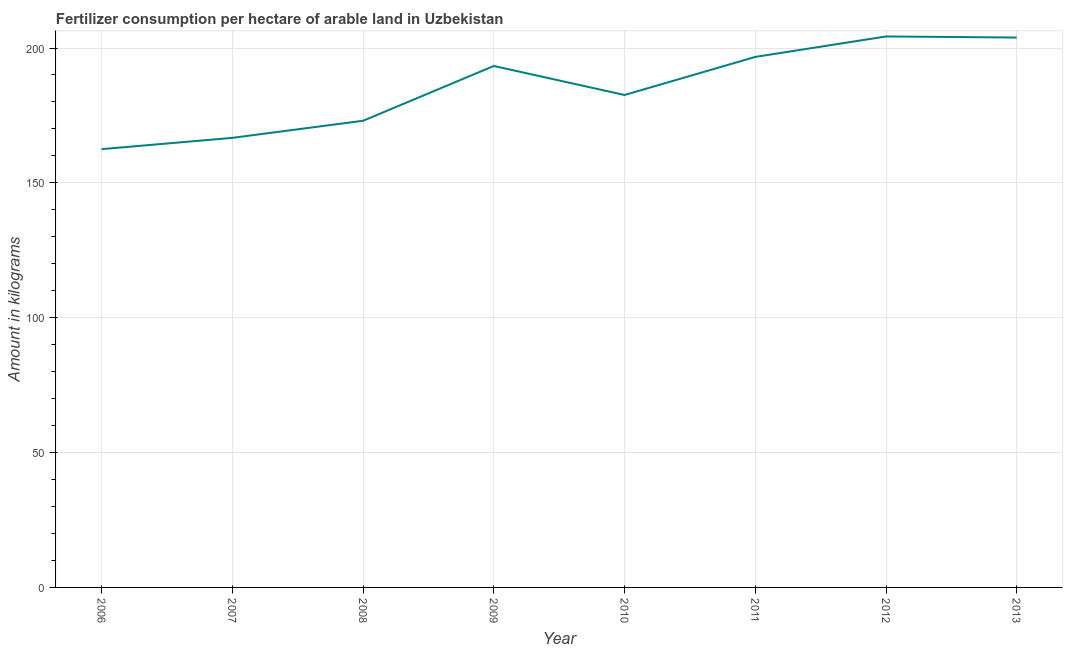What is the amount of fertilizer consumption in 2012?
Give a very brief answer. 204.28. Across all years, what is the maximum amount of fertilizer consumption?
Offer a terse response. 204.28. Across all years, what is the minimum amount of fertilizer consumption?
Provide a succinct answer. 162.5. In which year was the amount of fertilizer consumption minimum?
Keep it short and to the point. 2006. What is the sum of the amount of fertilizer consumption?
Give a very brief answer. 1482.98. What is the difference between the amount of fertilizer consumption in 2009 and 2011?
Give a very brief answer. -3.36. What is the average amount of fertilizer consumption per year?
Make the answer very short. 185.37. What is the median amount of fertilizer consumption?
Provide a succinct answer. 187.96. In how many years, is the amount of fertilizer consumption greater than 90 kg?
Your response must be concise. 8. What is the ratio of the amount of fertilizer consumption in 2009 to that in 2011?
Provide a short and direct response. 0.98. Is the amount of fertilizer consumption in 2006 less than that in 2011?
Make the answer very short. Yes. Is the difference between the amount of fertilizer consumption in 2011 and 2012 greater than the difference between any two years?
Ensure brevity in your answer.  No. What is the difference between the highest and the second highest amount of fertilizer consumption?
Your answer should be compact. 0.4. What is the difference between the highest and the lowest amount of fertilizer consumption?
Your answer should be very brief. 41.78. Does the amount of fertilizer consumption monotonically increase over the years?
Provide a succinct answer. No. What is the difference between two consecutive major ticks on the Y-axis?
Ensure brevity in your answer.  50. What is the title of the graph?
Offer a very short reply. Fertilizer consumption per hectare of arable land in Uzbekistan . What is the label or title of the Y-axis?
Your response must be concise. Amount in kilograms. What is the Amount in kilograms of 2006?
Keep it short and to the point. 162.5. What is the Amount in kilograms in 2007?
Make the answer very short. 166.69. What is the Amount in kilograms in 2008?
Your answer should be very brief. 173.02. What is the Amount in kilograms in 2009?
Keep it short and to the point. 193.34. What is the Amount in kilograms of 2010?
Your response must be concise. 182.58. What is the Amount in kilograms of 2011?
Your answer should be very brief. 196.7. What is the Amount in kilograms of 2012?
Ensure brevity in your answer.  204.28. What is the Amount in kilograms of 2013?
Your response must be concise. 203.88. What is the difference between the Amount in kilograms in 2006 and 2007?
Provide a short and direct response. -4.19. What is the difference between the Amount in kilograms in 2006 and 2008?
Ensure brevity in your answer.  -10.52. What is the difference between the Amount in kilograms in 2006 and 2009?
Provide a short and direct response. -30.84. What is the difference between the Amount in kilograms in 2006 and 2010?
Your answer should be compact. -20.08. What is the difference between the Amount in kilograms in 2006 and 2011?
Ensure brevity in your answer.  -34.2. What is the difference between the Amount in kilograms in 2006 and 2012?
Keep it short and to the point. -41.78. What is the difference between the Amount in kilograms in 2006 and 2013?
Your answer should be compact. -41.38. What is the difference between the Amount in kilograms in 2007 and 2008?
Provide a short and direct response. -6.33. What is the difference between the Amount in kilograms in 2007 and 2009?
Provide a succinct answer. -26.65. What is the difference between the Amount in kilograms in 2007 and 2010?
Offer a very short reply. -15.89. What is the difference between the Amount in kilograms in 2007 and 2011?
Your answer should be very brief. -30.01. What is the difference between the Amount in kilograms in 2007 and 2012?
Offer a terse response. -37.6. What is the difference between the Amount in kilograms in 2007 and 2013?
Offer a very short reply. -37.2. What is the difference between the Amount in kilograms in 2008 and 2009?
Your response must be concise. -20.32. What is the difference between the Amount in kilograms in 2008 and 2010?
Offer a terse response. -9.56. What is the difference between the Amount in kilograms in 2008 and 2011?
Offer a very short reply. -23.68. What is the difference between the Amount in kilograms in 2008 and 2012?
Your response must be concise. -31.26. What is the difference between the Amount in kilograms in 2008 and 2013?
Offer a very short reply. -30.86. What is the difference between the Amount in kilograms in 2009 and 2010?
Your answer should be very brief. 10.75. What is the difference between the Amount in kilograms in 2009 and 2011?
Give a very brief answer. -3.36. What is the difference between the Amount in kilograms in 2009 and 2012?
Your answer should be compact. -10.95. What is the difference between the Amount in kilograms in 2009 and 2013?
Give a very brief answer. -10.55. What is the difference between the Amount in kilograms in 2010 and 2011?
Provide a succinct answer. -14.11. What is the difference between the Amount in kilograms in 2010 and 2012?
Ensure brevity in your answer.  -21.7. What is the difference between the Amount in kilograms in 2010 and 2013?
Offer a terse response. -21.3. What is the difference between the Amount in kilograms in 2011 and 2012?
Provide a succinct answer. -7.59. What is the difference between the Amount in kilograms in 2011 and 2013?
Keep it short and to the point. -7.19. What is the difference between the Amount in kilograms in 2012 and 2013?
Ensure brevity in your answer.  0.4. What is the ratio of the Amount in kilograms in 2006 to that in 2008?
Your response must be concise. 0.94. What is the ratio of the Amount in kilograms in 2006 to that in 2009?
Your answer should be very brief. 0.84. What is the ratio of the Amount in kilograms in 2006 to that in 2010?
Give a very brief answer. 0.89. What is the ratio of the Amount in kilograms in 2006 to that in 2011?
Ensure brevity in your answer.  0.83. What is the ratio of the Amount in kilograms in 2006 to that in 2012?
Ensure brevity in your answer.  0.8. What is the ratio of the Amount in kilograms in 2006 to that in 2013?
Your answer should be compact. 0.8. What is the ratio of the Amount in kilograms in 2007 to that in 2009?
Keep it short and to the point. 0.86. What is the ratio of the Amount in kilograms in 2007 to that in 2011?
Provide a short and direct response. 0.85. What is the ratio of the Amount in kilograms in 2007 to that in 2012?
Give a very brief answer. 0.82. What is the ratio of the Amount in kilograms in 2007 to that in 2013?
Keep it short and to the point. 0.82. What is the ratio of the Amount in kilograms in 2008 to that in 2009?
Provide a short and direct response. 0.9. What is the ratio of the Amount in kilograms in 2008 to that in 2010?
Offer a very short reply. 0.95. What is the ratio of the Amount in kilograms in 2008 to that in 2011?
Your response must be concise. 0.88. What is the ratio of the Amount in kilograms in 2008 to that in 2012?
Your answer should be compact. 0.85. What is the ratio of the Amount in kilograms in 2008 to that in 2013?
Provide a short and direct response. 0.85. What is the ratio of the Amount in kilograms in 2009 to that in 2010?
Offer a very short reply. 1.06. What is the ratio of the Amount in kilograms in 2009 to that in 2011?
Keep it short and to the point. 0.98. What is the ratio of the Amount in kilograms in 2009 to that in 2012?
Keep it short and to the point. 0.95. What is the ratio of the Amount in kilograms in 2009 to that in 2013?
Provide a short and direct response. 0.95. What is the ratio of the Amount in kilograms in 2010 to that in 2011?
Make the answer very short. 0.93. What is the ratio of the Amount in kilograms in 2010 to that in 2012?
Give a very brief answer. 0.89. What is the ratio of the Amount in kilograms in 2010 to that in 2013?
Give a very brief answer. 0.9. What is the ratio of the Amount in kilograms in 2011 to that in 2013?
Ensure brevity in your answer.  0.96. What is the ratio of the Amount in kilograms in 2012 to that in 2013?
Provide a short and direct response. 1. 